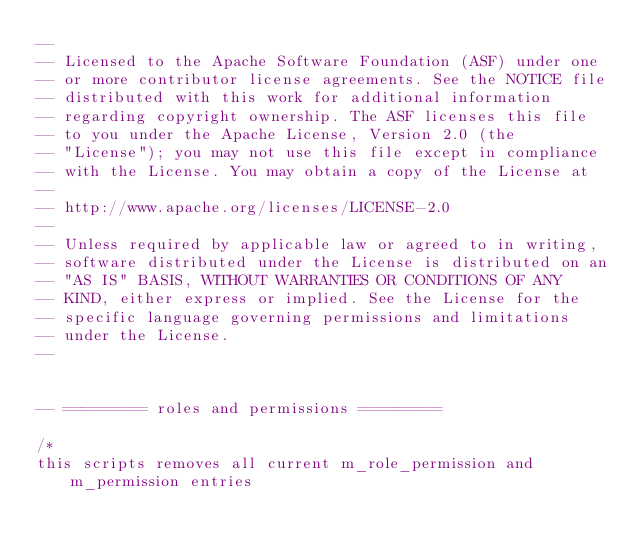Convert code to text. <code><loc_0><loc_0><loc_500><loc_500><_SQL_>--
-- Licensed to the Apache Software Foundation (ASF) under one
-- or more contributor license agreements. See the NOTICE file
-- distributed with this work for additional information
-- regarding copyright ownership. The ASF licenses this file
-- to you under the Apache License, Version 2.0 (the
-- "License"); you may not use this file except in compliance
-- with the License. You may obtain a copy of the License at
--
-- http://www.apache.org/licenses/LICENSE-2.0
--
-- Unless required by applicable law or agreed to in writing,
-- software distributed under the License is distributed on an
-- "AS IS" BASIS, WITHOUT WARRANTIES OR CONDITIONS OF ANY
-- KIND, either express or implied. See the License for the
-- specific language governing permissions and limitations
-- under the License.
--


-- ========= roles and permissions =========

/*
this scripts removes all current m_role_permission and m_permission entries</code> 